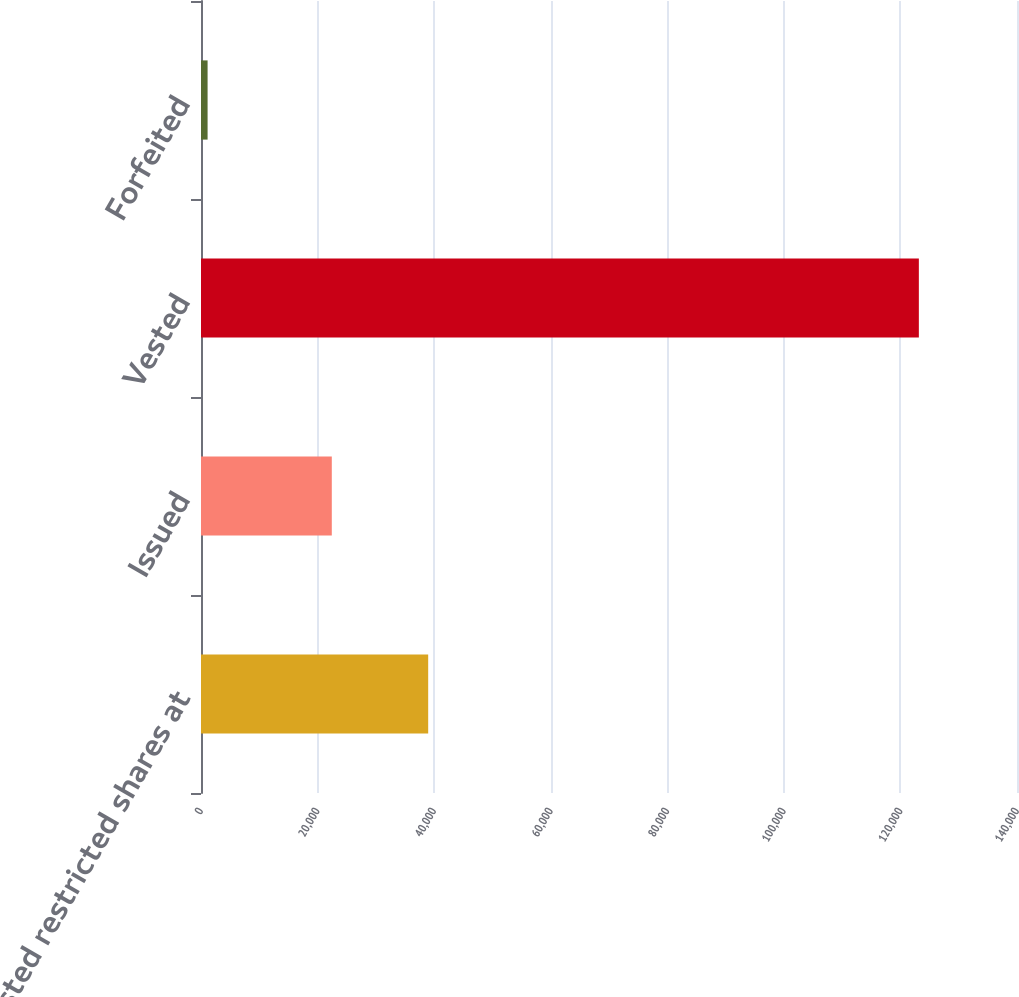Convert chart to OTSL. <chart><loc_0><loc_0><loc_500><loc_500><bar_chart><fcel>Nonvested restricted shares at<fcel>Issued<fcel>Vested<fcel>Forfeited<nl><fcel>38978<fcel>22441<fcel>123161<fcel>1130<nl></chart> 